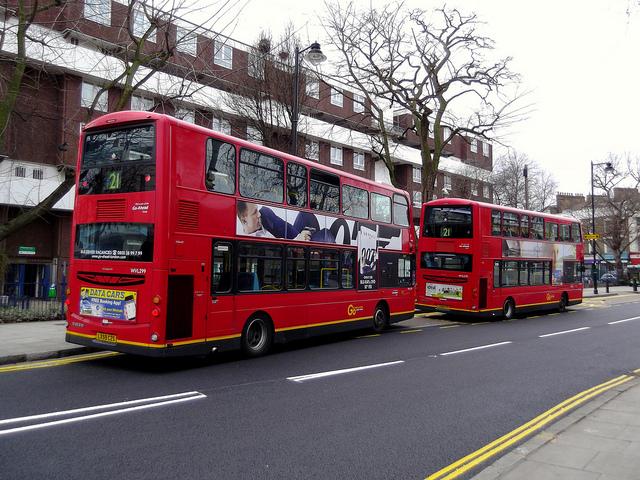These buses are named what?
Answer briefly. Double decker. How many buses are there?
Short answer required. 2. What movie is being advertised on the first bus?
Answer briefly. 007. 